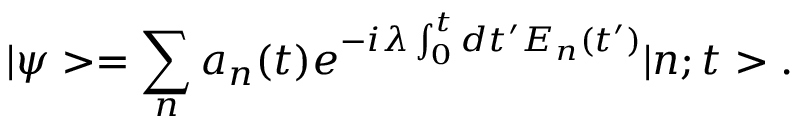Convert formula to latex. <formula><loc_0><loc_0><loc_500><loc_500>| \psi > = \sum _ { n } a _ { n } ( t ) e ^ { - i \lambda \int _ { 0 } ^ { t } d t ^ { \prime } E _ { n } ( t ^ { \prime } ) } | n ; t > .</formula> 